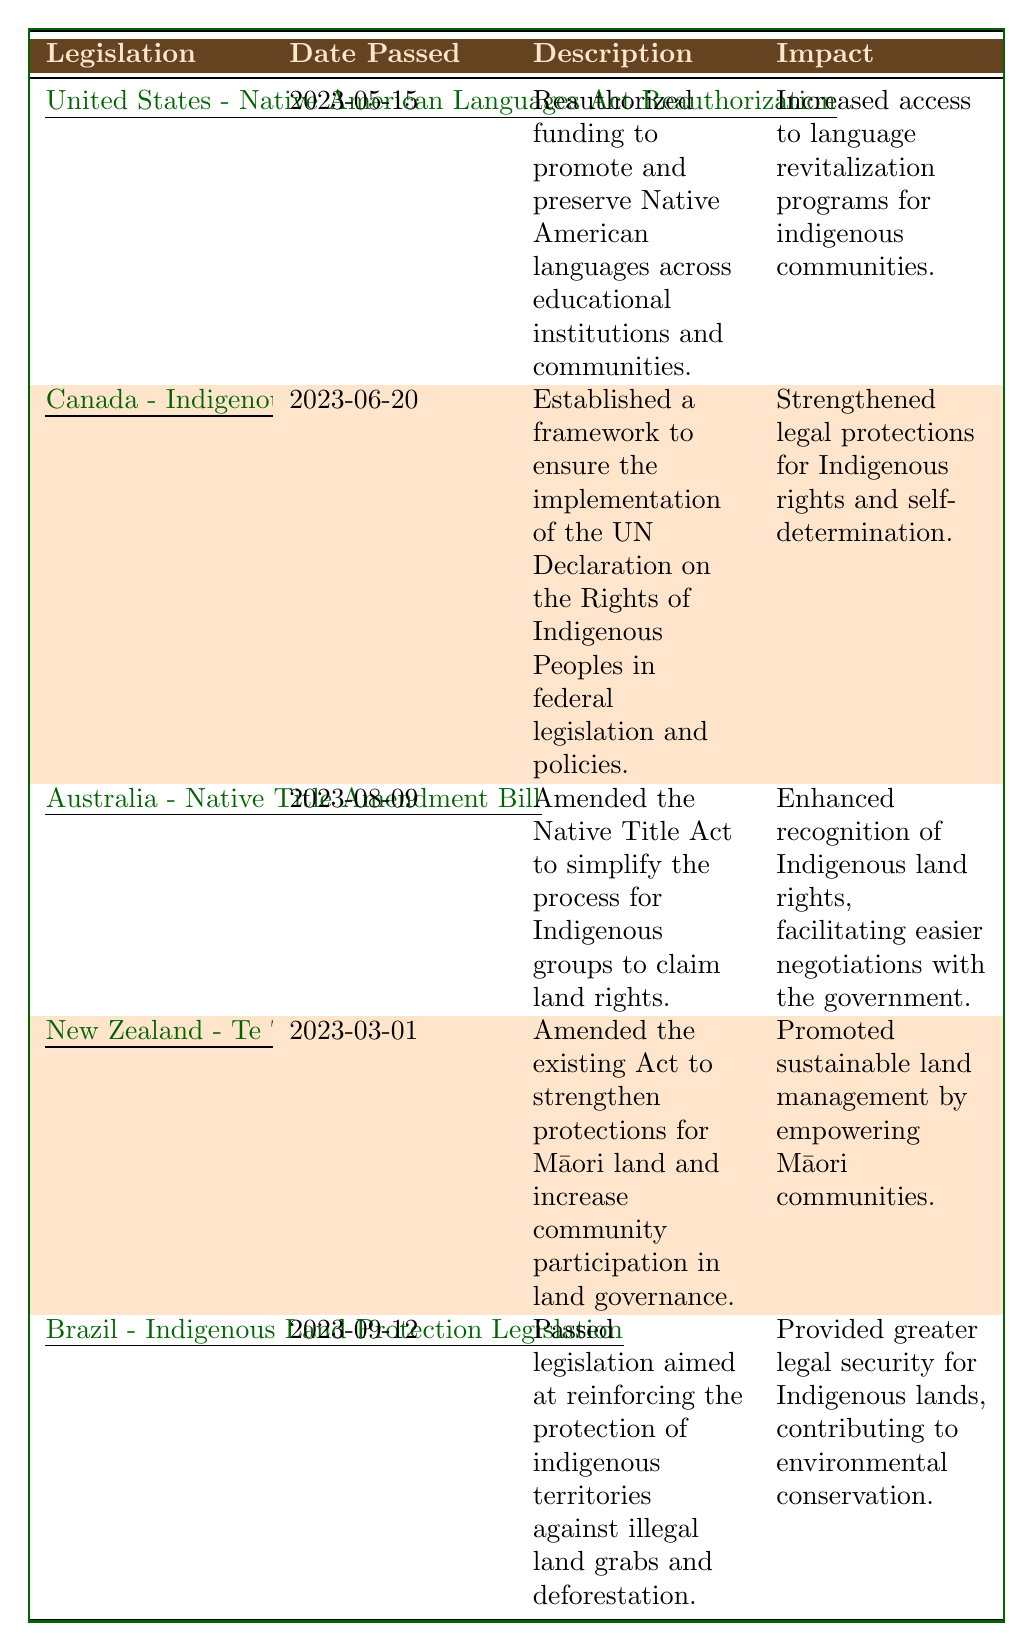What is the title of the legislation passed on March 1, 2023? The table lists the legislation titles along with their corresponding dates. By locating the date "2023-03-01," we can see that the title of the legislation is "Te Ture Whenua Māori Act Amendment."
Answer: Te Ture Whenua Māori Act Amendment How many pieces of legislation were passed in 2023 that specifically focus on land rights? According to the table, there are two pieces of legislation that specifically mention land rights: the "Australia - Native Title Amendment Bill" and the "New Zealand - Te Ture Whenua Māori Act Amendment." Therefore, the count is 2.
Answer: 2 What impact did the "Brazil - Indigenous Land Protection Legislation" aim to achieve? Looking at the impact column for the "Brazil - Indigenous Land Protection Legislation," it states that it aimed to provide greater legal security for Indigenous lands, contributing to environmental conservation.
Answer: Greater legal security for Indigenous lands Is there any legislation passed to promote Indigenous languages? The table shows the "United States - Native American Languages Act Reauthorization," which specifically focuses on promoting and preserving Native American languages. Therefore, the answer is yes.
Answer: Yes Which legislation was passed last among the five listed? To determine this, we compare the dates listed in the table. The last date in chronological order is "2023-09-12" for the "Brazil - Indigenous Land Protection Legislation," indicating that it was passed last.
Answer: Brazil - Indigenous Land Protection Legislation What is the main purpose of the "Canada - Indigenous Rights Framework Implementation Act"? In the table, the description states that it was established to ensure the implementation of the UN Declaration on the Rights of Indigenous Peoples in federal legislation and policies. Therefore, the main purpose is to support the UN Declaration in legislation.
Answer: To ensure implementation of the UN Declaration How many of the listed legislations aim to strengthen legal protections for Indigenous peoples? Reviewing the impact descriptions, both the "Canada - Indigenous Rights Framework Implementation Act" and the "Brazil - Indigenous Land Protection Legislation" mention strengthening legal protections. So, there are 2 such legislations.
Answer: 2 Which country had legislation that specifically mentioned community participation in land governance? The table specifies that the "New Zealand - Te Ture Whenua Māori Act Amendment" aims to increase community participation in land governance, indicating New Zealand is the country mentioned.
Answer: New Zealand Which piece of legislation passed first in 2023, and what was its impact? The earliest date in the table is "2023-03-01," corresponding to the "New Zealand - Te Ture Whenua Māori Act Amendment." Its impact was promoting sustainable land management by empowering Māori communities.
Answer: New Zealand - Te Ture Whenua Māori Act Amendment; promote sustainable land management What common theme is shared among the impacts of the legislation related to Indigenous rights passed in 2023? By analyzing the impacts listed, a common theme is the focus on recognition, protection, and empowerment of Indigenous communities, reflecting a broader goal of enhancing Indigenous rights and self-determination.
Answer: Recognition and empowerment of Indigenous rights How many countries are represented by the legislations listed in the table? The table references legislations from five distinct countries: the United States, Canada, Australia, New Zealand, and Brazil. This reveals that there are 5 countries represented.
Answer: 5 